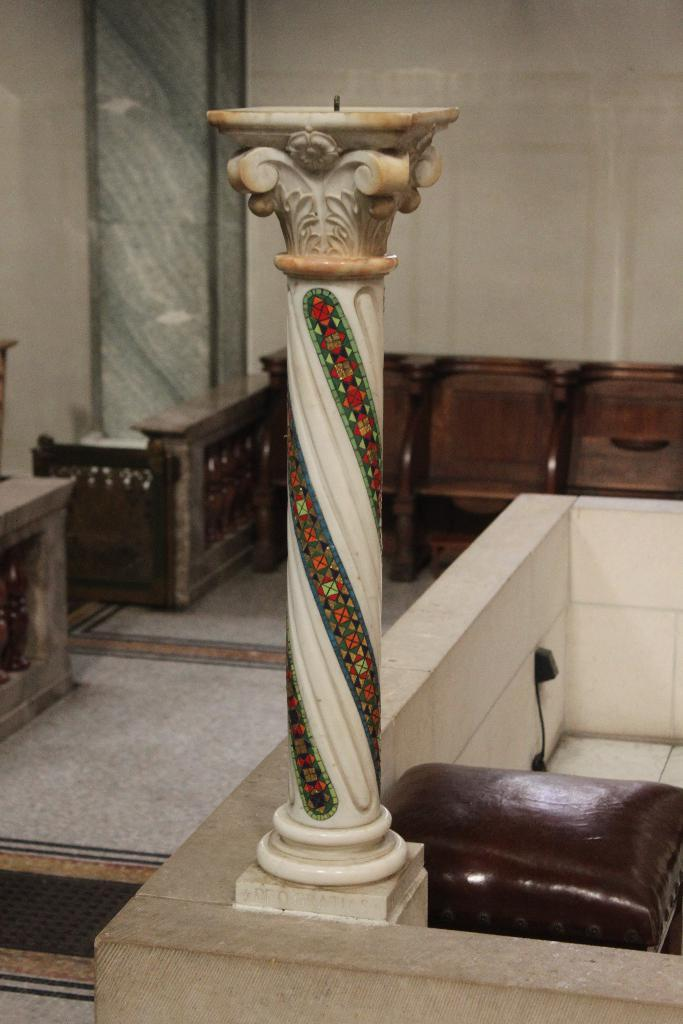What is on the wall in the image? There is a pillar on the wall in the image. What is located next to the pillar? There is an object to the side of the pillar. What type of objects can be seen in the background of the image? There are wooden objects visible in the background of the image. What is the main feature of the image? The wall is present in the image. What date is circled on the calendar in the image? There is no calendar present in the image, so it is not possible to answer that question. 